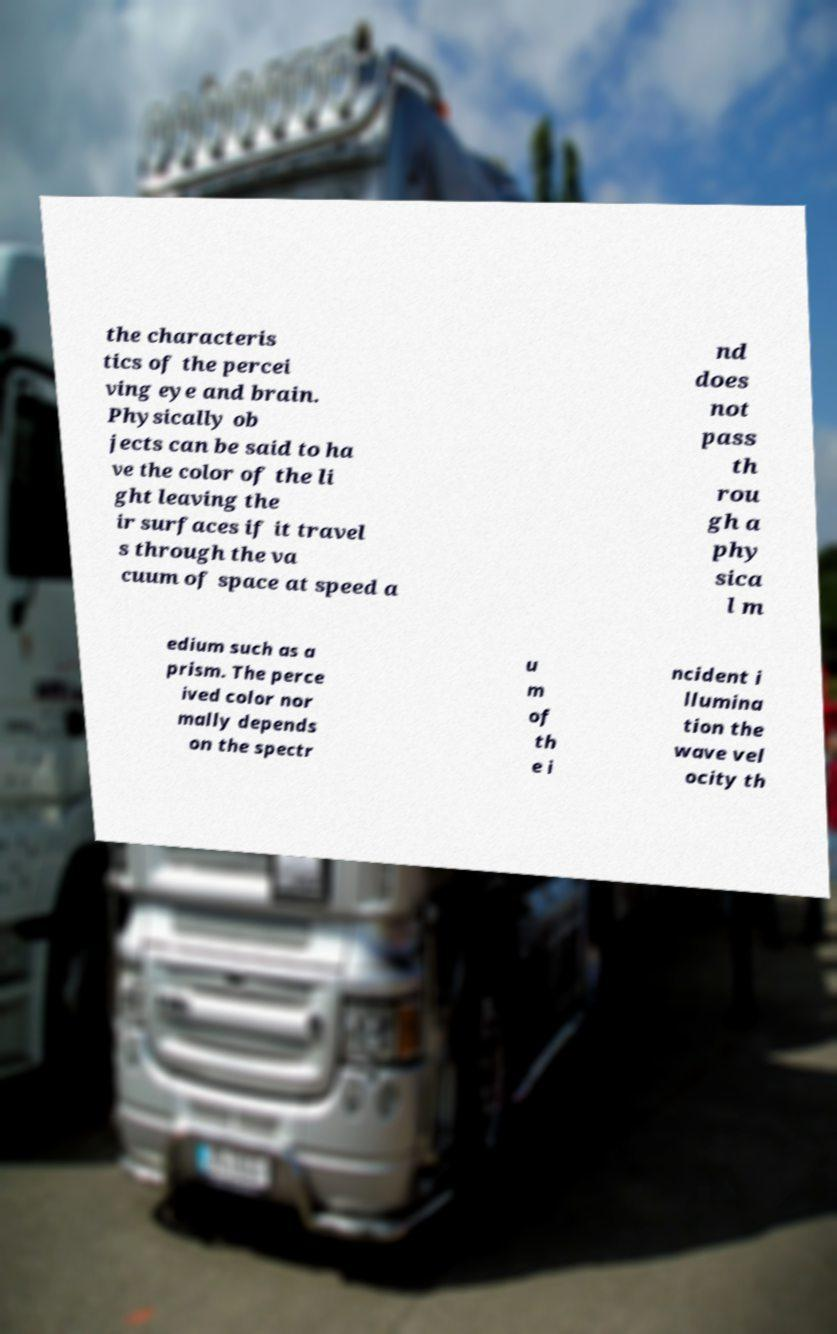There's text embedded in this image that I need extracted. Can you transcribe it verbatim? the characteris tics of the percei ving eye and brain. Physically ob jects can be said to ha ve the color of the li ght leaving the ir surfaces if it travel s through the va cuum of space at speed a nd does not pass th rou gh a phy sica l m edium such as a prism. The perce ived color nor mally depends on the spectr u m of th e i ncident i llumina tion the wave vel ocity th 